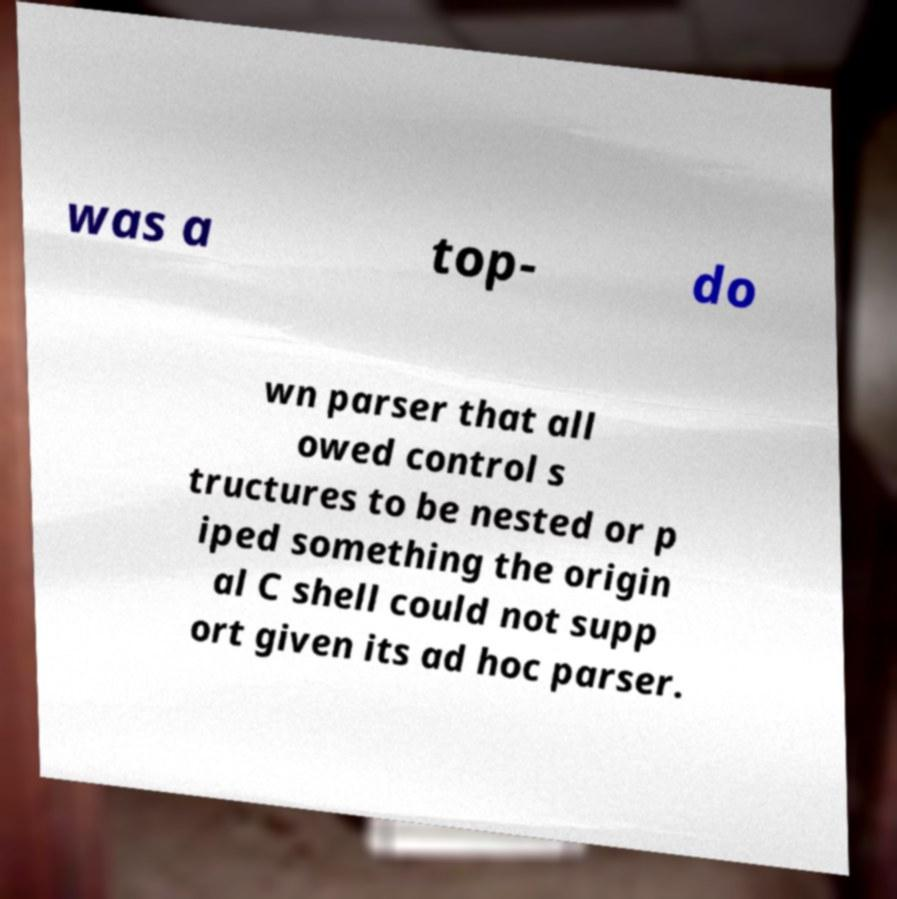Please identify and transcribe the text found in this image. was a top- do wn parser that all owed control s tructures to be nested or p iped something the origin al C shell could not supp ort given its ad hoc parser. 